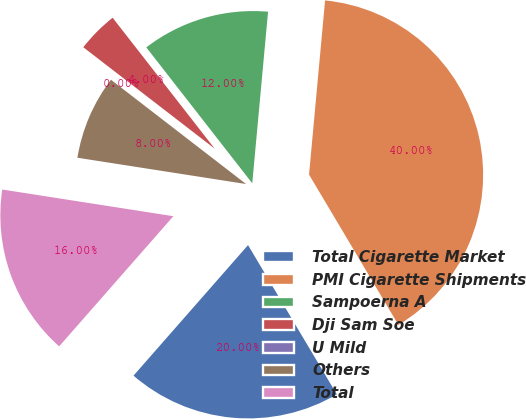Convert chart. <chart><loc_0><loc_0><loc_500><loc_500><pie_chart><fcel>Total Cigarette Market<fcel>PMI Cigarette Shipments<fcel>Sampoerna A<fcel>Dji Sam Soe<fcel>U Mild<fcel>Others<fcel>Total<nl><fcel>20.0%<fcel>40.0%<fcel>12.0%<fcel>4.0%<fcel>0.0%<fcel>8.0%<fcel>16.0%<nl></chart> 